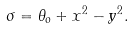Convert formula to latex. <formula><loc_0><loc_0><loc_500><loc_500>\sigma = \theta _ { o } + x ^ { 2 } - y ^ { 2 } .</formula> 